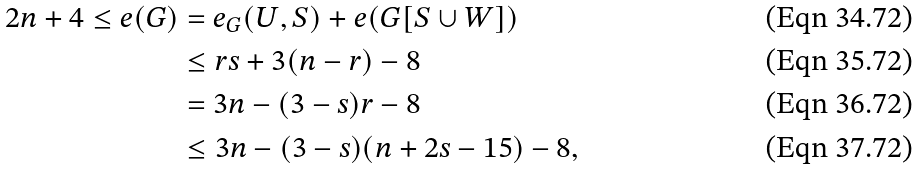<formula> <loc_0><loc_0><loc_500><loc_500>2 n + 4 \leq e ( G ) & = e _ { G } ( U , S ) + e ( G [ S \cup W ] ) \\ & \leq r s + 3 ( n - r ) - 8 \\ & = 3 n - ( 3 - s ) r - 8 \\ & \leq 3 n - ( 3 - s ) ( n + 2 s - 1 5 ) - 8 ,</formula> 